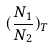<formula> <loc_0><loc_0><loc_500><loc_500>( \frac { N _ { 1 } } { N _ { 2 } } ) _ { T }</formula> 